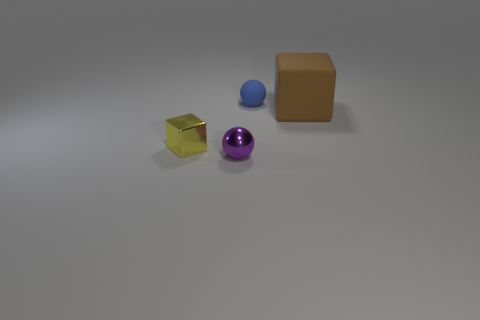What time of day do you think it is in this scene based on the lighting? The lighting in this image is quite neutral and does not give away any definite cues about the time of day. It could likely be an indoor setting with artificial lighting that is evenly distributed throughout the scene. There are no shadows or light patterns that would typically indicate natural light sources such as the sun during different times of day. 